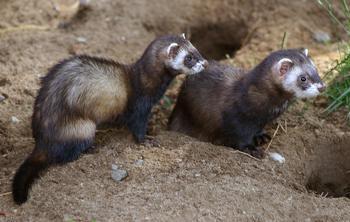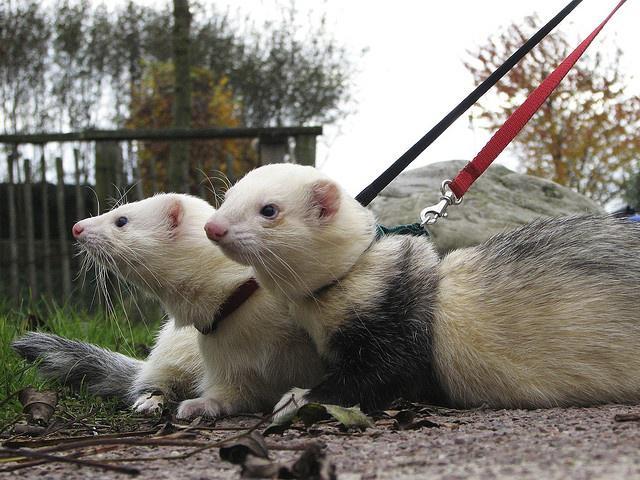The first image is the image on the left, the second image is the image on the right. Assess this claim about the two images: "An image contains a human holding two ferrets.". Correct or not? Answer yes or no. No. 